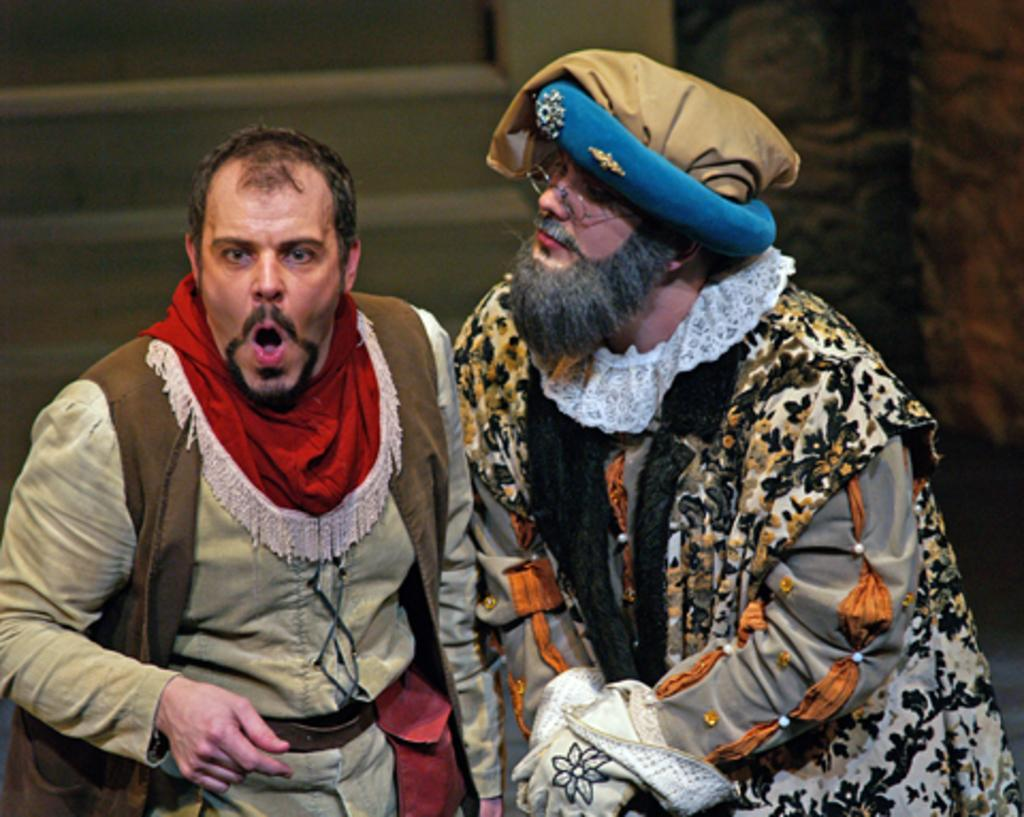How many men are present in the image? There are two men standing in the image. What is the man on the left doing? The man on the left has his mouth wide open. What can be seen behind the men? There are steps behind the men. What is located to the right of the men? There is a wall to the right of the men. What type of skirt is the man on the right wearing in the image? There is no skirt present in the image, as both men are wearing pants. What color is the powder that the men are using in the image? There is no powder visible in the image; the men are simply standing. 